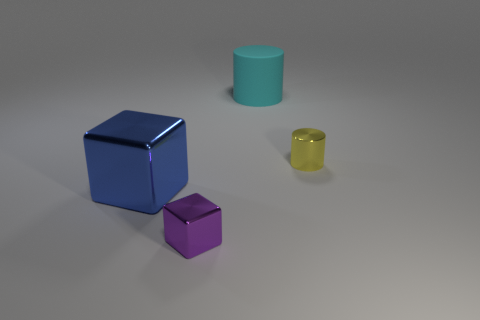What number of gray objects are the same size as the cyan rubber cylinder?
Offer a very short reply. 0. What is the color of the metallic thing that is both to the left of the big cyan cylinder and right of the blue metal object?
Your answer should be very brief. Purple. What number of objects are tiny yellow matte cubes or metal objects?
Keep it short and to the point. 3. How many small things are yellow cylinders or shiny cubes?
Your answer should be compact. 2. Are there any other things of the same color as the large cylinder?
Offer a terse response. No. What is the size of the metallic thing that is behind the tiny purple block and right of the blue metallic object?
Your answer should be very brief. Small. There is a tiny metallic thing that is to the left of the small yellow cylinder; is it the same color as the large object that is to the left of the cyan cylinder?
Offer a terse response. No. How many other objects are there of the same material as the large cyan thing?
Offer a very short reply. 0. The object that is on the left side of the large cyan object and on the right side of the big metallic object has what shape?
Keep it short and to the point. Cube. Does the big cylinder have the same color as the shiny cube that is behind the small purple thing?
Your answer should be compact. No. 